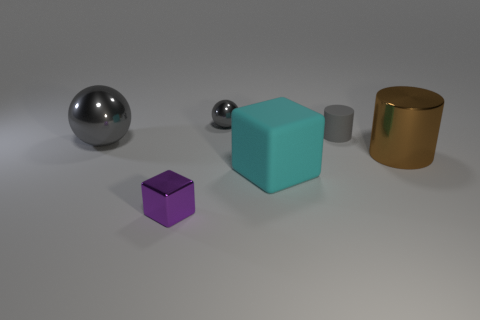Add 4 tiny blue shiny cubes. How many objects exist? 10 Subtract 2 cylinders. How many cylinders are left? 0 Subtract all red spheres. Subtract all blue cubes. How many spheres are left? 2 Subtract all brown spheres. How many brown cylinders are left? 1 Subtract all small matte things. Subtract all big cyan objects. How many objects are left? 4 Add 2 large cylinders. How many large cylinders are left? 3 Add 2 metal cylinders. How many metal cylinders exist? 3 Subtract all cyan cubes. How many cubes are left? 1 Subtract 0 blue balls. How many objects are left? 6 